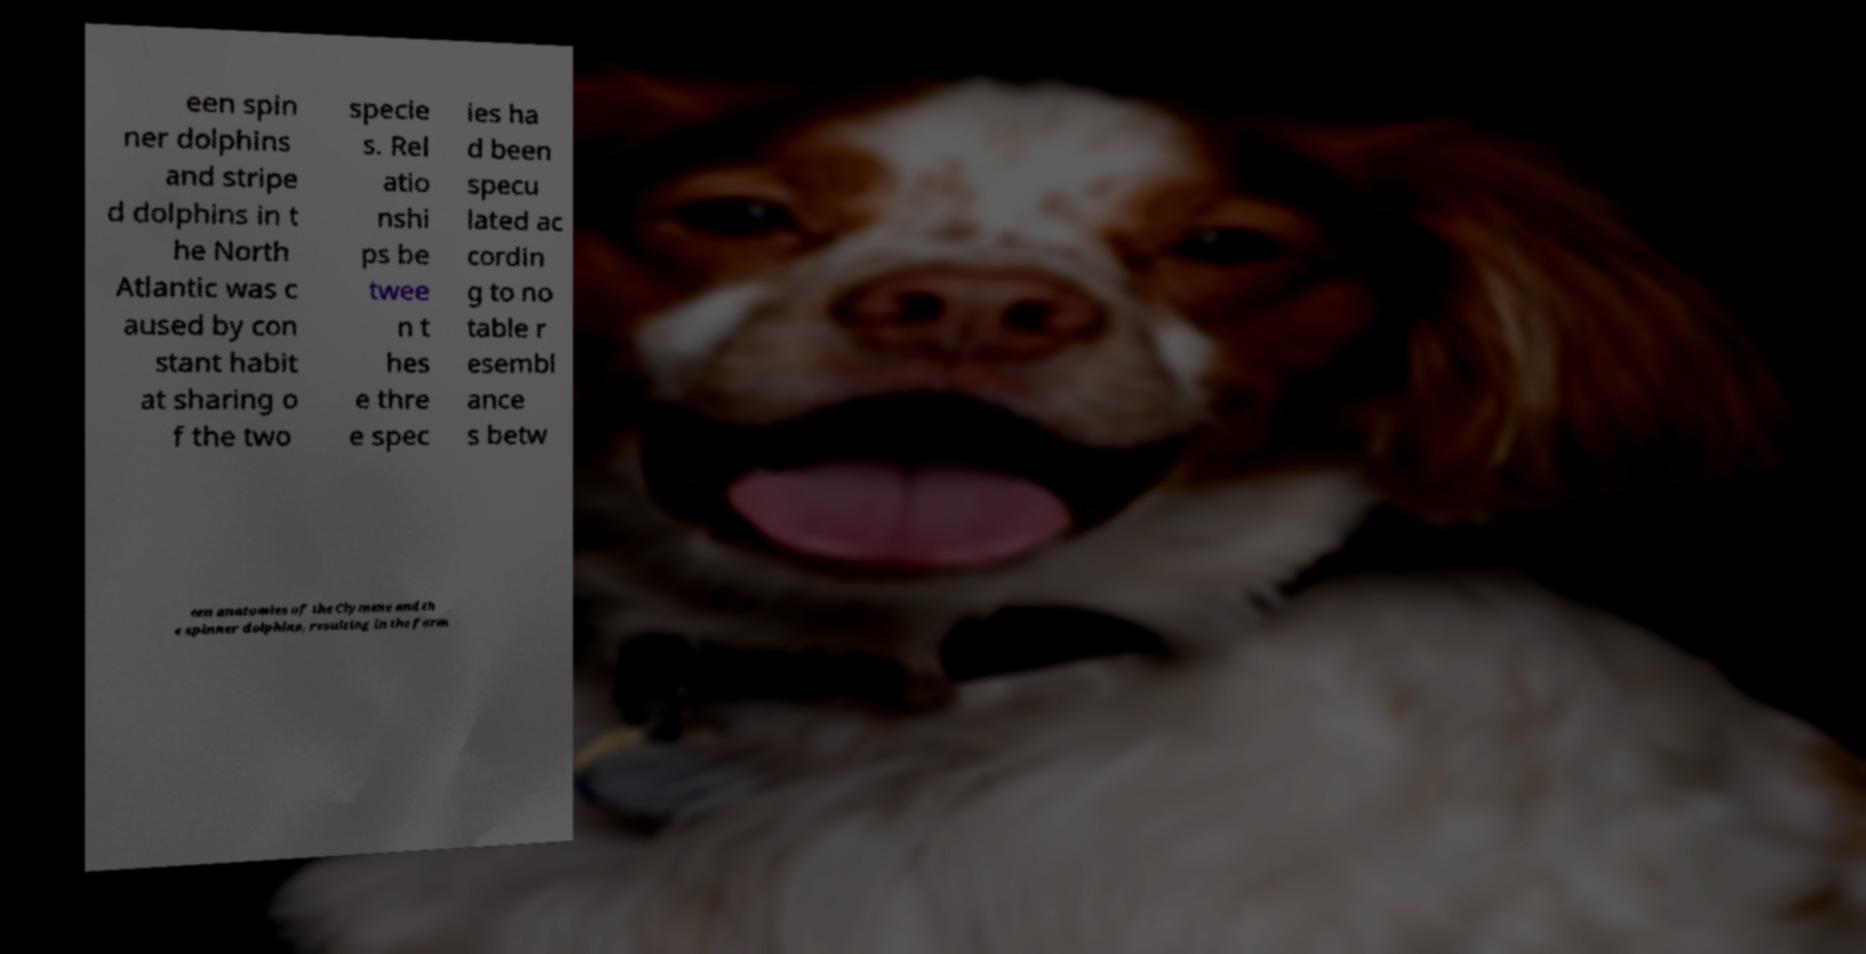Please read and relay the text visible in this image. What does it say? een spin ner dolphins and stripe d dolphins in t he North Atlantic was c aused by con stant habit at sharing o f the two specie s. Rel atio nshi ps be twee n t hes e thre e spec ies ha d been specu lated ac cordin g to no table r esembl ance s betw een anatomies of the Clymene and th e spinner dolphins, resulting in the form 